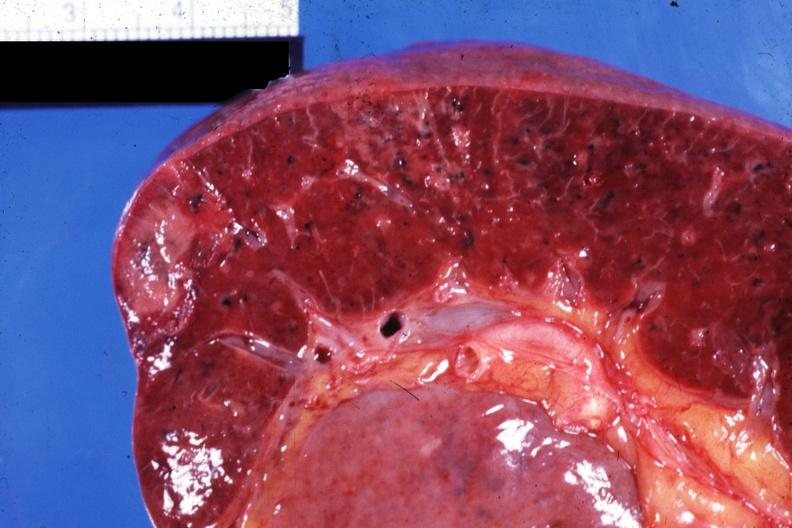s foot present?
Answer the question using a single word or phrase. No 